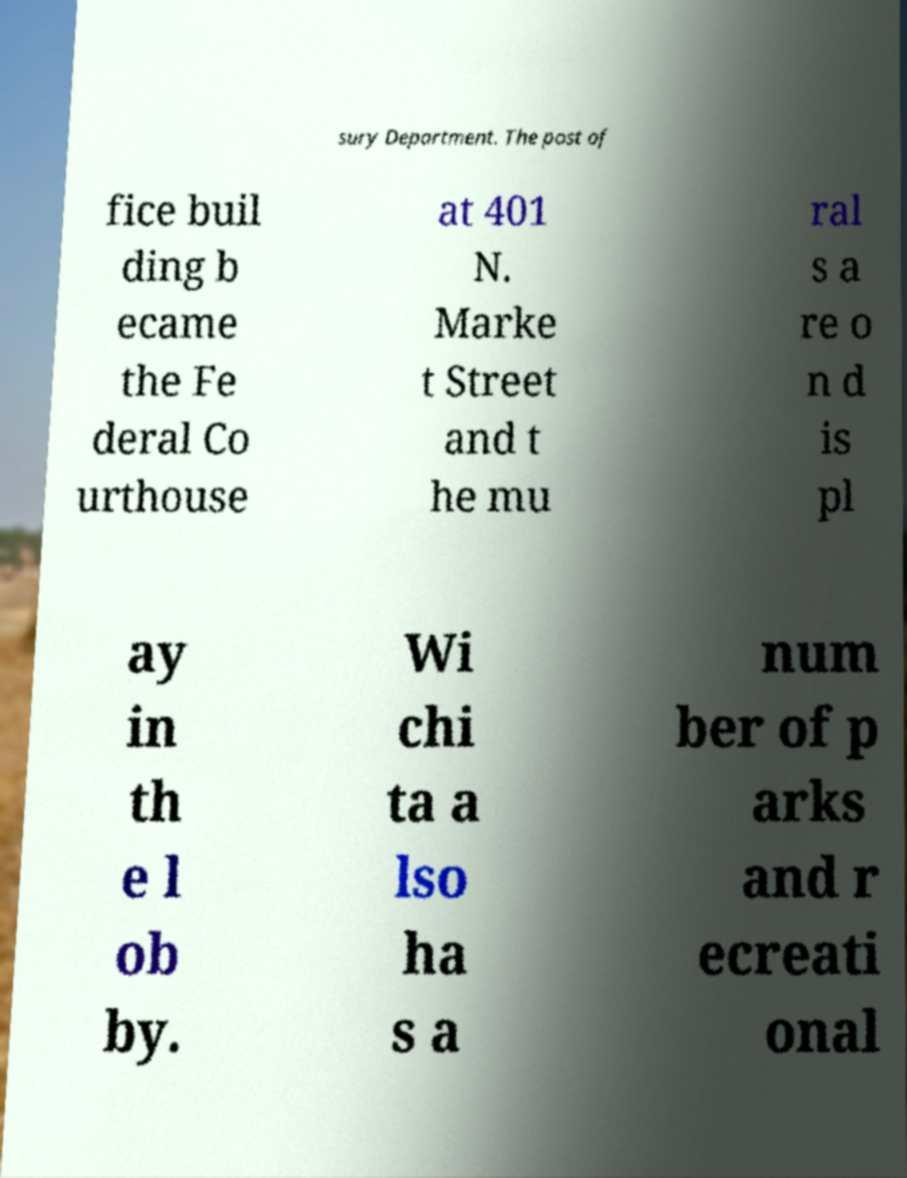What messages or text are displayed in this image? I need them in a readable, typed format. sury Department. The post of fice buil ding b ecame the Fe deral Co urthouse at 401 N. Marke t Street and t he mu ral s a re o n d is pl ay in th e l ob by. Wi chi ta a lso ha s a num ber of p arks and r ecreati onal 